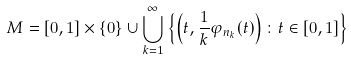Convert formula to latex. <formula><loc_0><loc_0><loc_500><loc_500>M = [ 0 , 1 ] \times \{ 0 \} \cup \bigcup _ { k = 1 } ^ { \infty } \left \{ \left ( t , \frac { 1 } { k } \varphi _ { n _ { k } } ( t ) \right ) \colon t \in [ 0 , 1 ] \right \}</formula> 